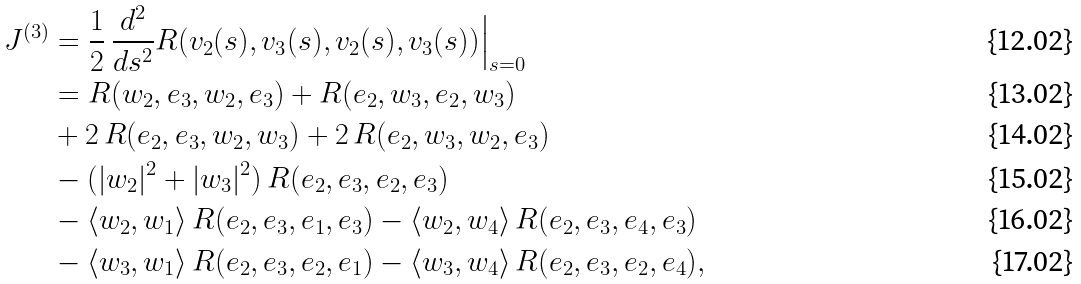Convert formula to latex. <formula><loc_0><loc_0><loc_500><loc_500>J ^ { ( 3 ) } & = \frac { 1 } { 2 } \, \frac { d ^ { 2 } } { d s ^ { 2 } } R ( v _ { 2 } ( s ) , v _ { 3 } ( s ) , v _ { 2 } ( s ) , v _ { 3 } ( s ) ) \Big | _ { s = 0 } \\ & = R ( w _ { 2 } , e _ { 3 } , w _ { 2 } , e _ { 3 } ) + R ( e _ { 2 } , w _ { 3 } , e _ { 2 } , w _ { 3 } ) \\ & + 2 \, R ( e _ { 2 } , e _ { 3 } , w _ { 2 } , w _ { 3 } ) + 2 \, R ( e _ { 2 } , w _ { 3 } , w _ { 2 } , e _ { 3 } ) \\ & - ( | w _ { 2 } | ^ { 2 } + | w _ { 3 } | ^ { 2 } ) \, R ( e _ { 2 } , e _ { 3 } , e _ { 2 } , e _ { 3 } ) \\ & - \langle w _ { 2 } , w _ { 1 } \rangle \, R ( e _ { 2 } , e _ { 3 } , e _ { 1 } , e _ { 3 } ) - \langle w _ { 2 } , w _ { 4 } \rangle \, R ( e _ { 2 } , e _ { 3 } , e _ { 4 } , e _ { 3 } ) \\ & - \langle w _ { 3 } , w _ { 1 } \rangle \, R ( e _ { 2 } , e _ { 3 } , e _ { 2 } , e _ { 1 } ) - \langle w _ { 3 } , w _ { 4 } \rangle \, R ( e _ { 2 } , e _ { 3 } , e _ { 2 } , e _ { 4 } ) ,</formula> 